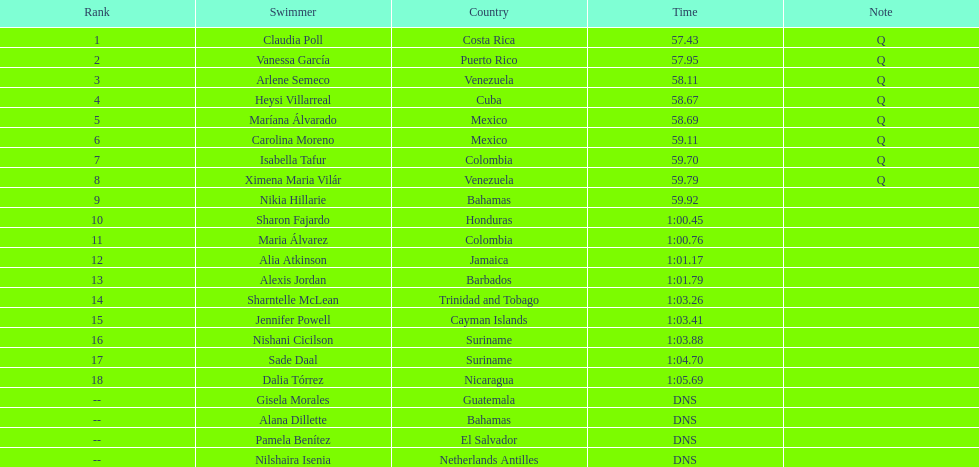Who completed after claudia poll? Vanessa García. 